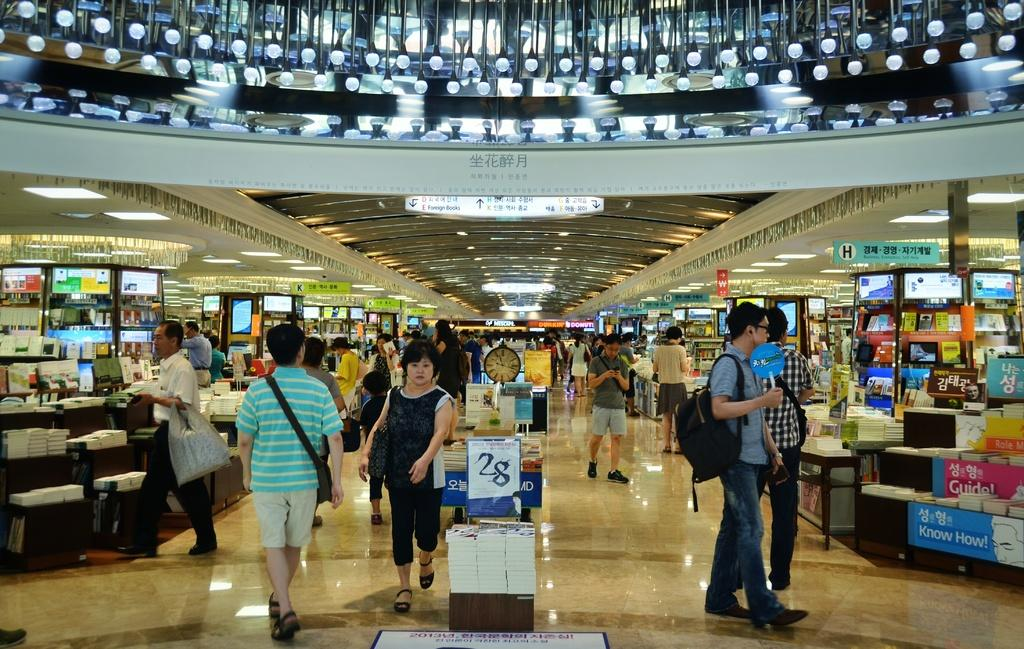<image>
Offer a succinct explanation of the picture presented. Foreign books can be found in section E. 